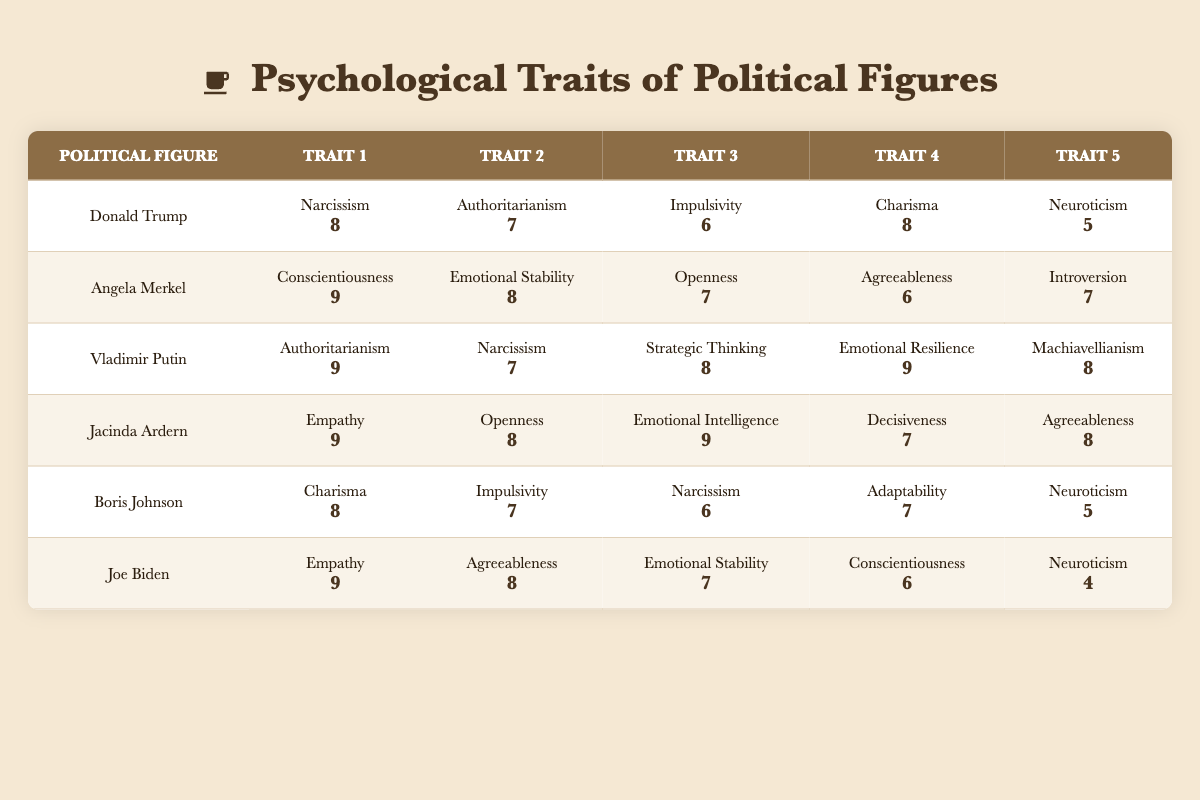What is the highest score for narcissism among the political figures listed? The highest score for narcissism is 8, which is shared by Donald Trump and Vladimir Putin.
Answer: 8 Which political figure has the lowest score in neuroticism? Joe Biden has the lowest score in neuroticism, with a score of 4.
Answer: 4 Calculate the average score for openness among the political figures. The scores for openness are 7 (Merkel), 7 (Boris Johnson), and 8 (Jacinda Ardern). Adding these gives 22, then dividing by 3 gives an average of 7.33.
Answer: 7.33 Is Angela Merkel more conscientious than Jacinda Ardern is empathetic? Angela Merkel has a score of 9 in conscientiousness, while Jacinda Ardern has a score of 9 in empathy; hence, they are equal.
Answer: No Which political figure scored the highest in emotional intelligence? Jacinda Ardern scored the highest in emotional intelligence with a score of 9.
Answer: Jacinda Ardern What is the total score for charisma across all political figures? The scores for charisma are 8 (Trump), 8 (Boris Johnson), which sum up to 16.
Answer: 16 Does Vladimir Putin have a higher score in strategic thinking than Joe Biden in empathy? Vladimir Putin has a score of 8 in strategic thinking, while Joe Biden has a score of 9 in empathy; hence, the statement is false.
Answer: No Calculate the difference in scores between the highest and lowest for agreeableness. The highest score for agreeableness is 8 (Jacinda Ardern, Joe Biden), and the lowest is 6 (Angela Merkel). The difference is 8 - 6 = 2.
Answer: 2 Which political figure exhibits the highest level of authoritarianism? Vladimir Putin exhibits the highest level of authoritarianism with a score of 9, compared to Trump's 7 and Merkel's absence of this trait.
Answer: Vladimir Putin 